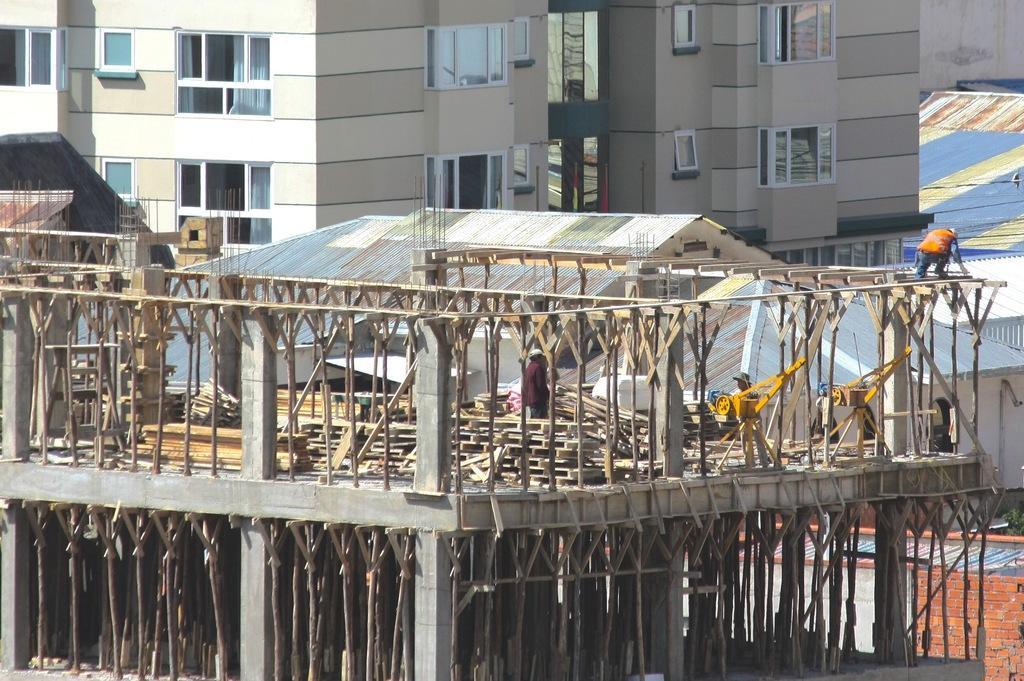Can you describe this image briefly? In this image there are buildings. In the foreground there is a building in construction. There are a few people standing on that building. Behind it there is a roof of another building. There are glass windows to the walls of the building. 